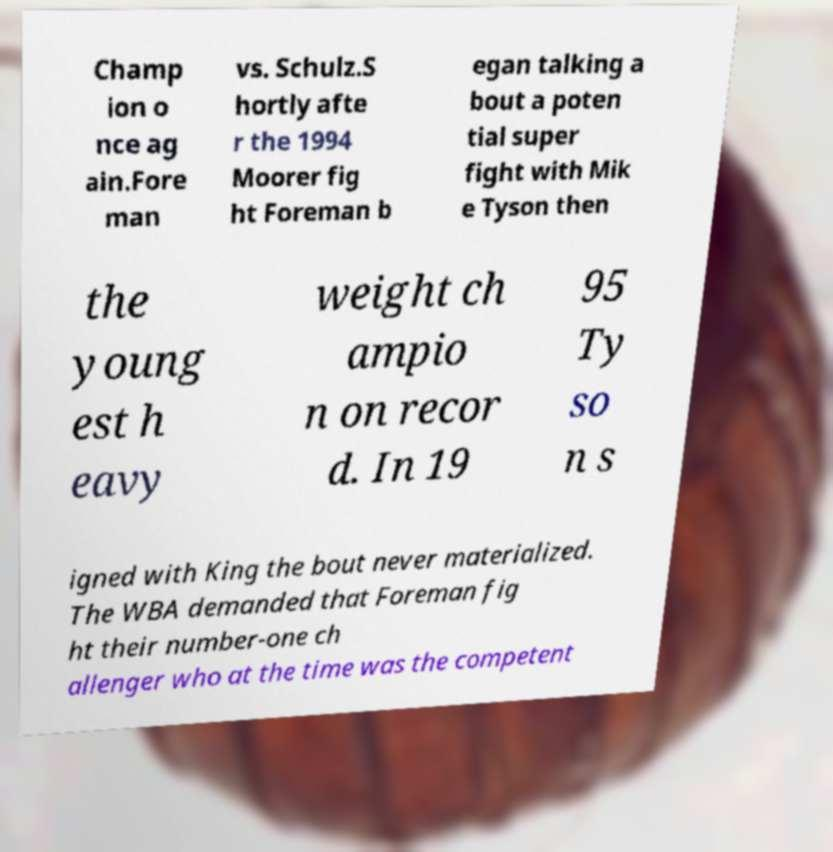For documentation purposes, I need the text within this image transcribed. Could you provide that? Champ ion o nce ag ain.Fore man vs. Schulz.S hortly afte r the 1994 Moorer fig ht Foreman b egan talking a bout a poten tial super fight with Mik e Tyson then the young est h eavy weight ch ampio n on recor d. In 19 95 Ty so n s igned with King the bout never materialized. The WBA demanded that Foreman fig ht their number-one ch allenger who at the time was the competent 